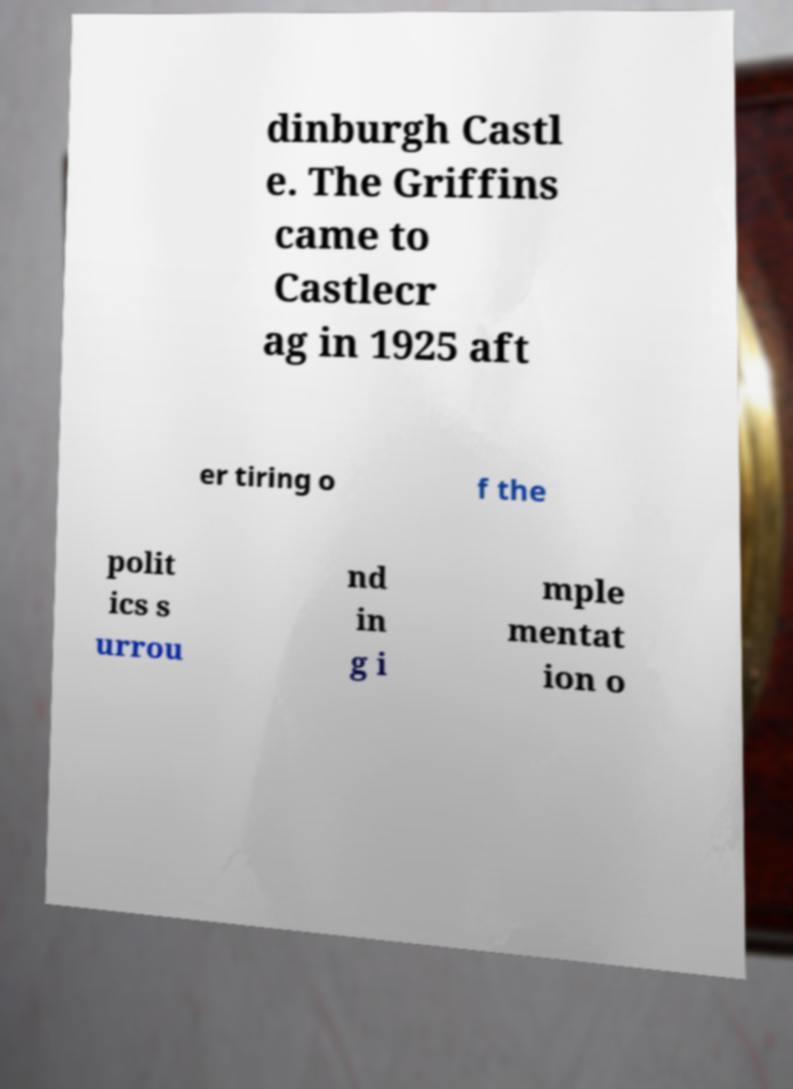Please read and relay the text visible in this image. What does it say? dinburgh Castl e. The Griffins came to Castlecr ag in 1925 aft er tiring o f the polit ics s urrou nd in g i mple mentat ion o 